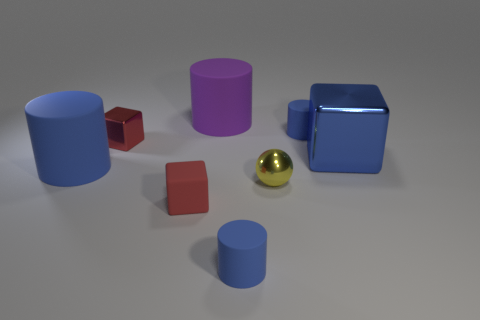There is a tiny blue cylinder that is left of the blue matte thing behind the blue block; is there a yellow metal ball that is left of it?
Ensure brevity in your answer.  No. The red thing that is the same material as the big blue cylinder is what shape?
Provide a short and direct response. Cube. Is there any other thing that has the same shape as the big blue metal object?
Make the answer very short. Yes. What shape is the tiny red matte object?
Your answer should be very brief. Cube. Do the large blue object that is on the right side of the rubber block and the purple thing have the same shape?
Give a very brief answer. No. Is the number of small cylinders that are on the left side of the small yellow shiny object greater than the number of blue metal blocks that are behind the blue metal thing?
Your response must be concise. Yes. What number of other things are the same size as the blue metal thing?
Your answer should be very brief. 2. Does the yellow shiny thing have the same shape as the big object on the right side of the purple cylinder?
Provide a short and direct response. No. What number of shiny things are cylinders or small spheres?
Provide a succinct answer. 1. Is there another sphere that has the same color as the tiny ball?
Ensure brevity in your answer.  No. 